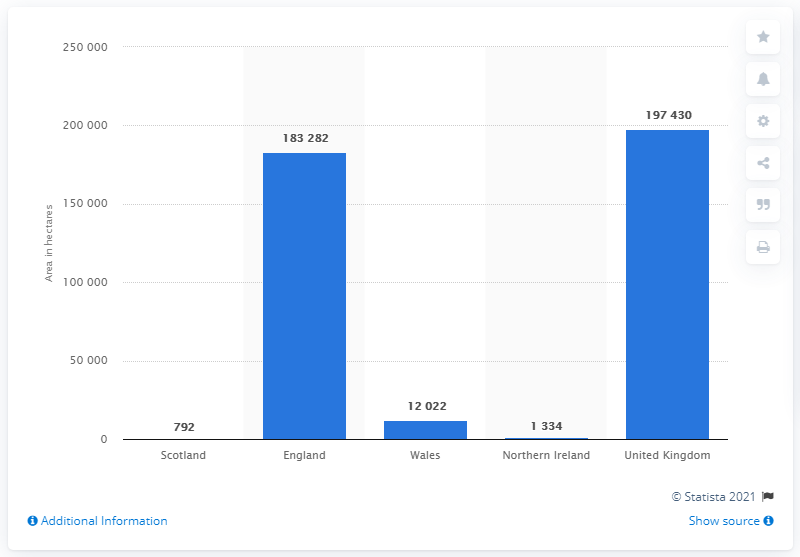Specify some key components in this picture. In June 2017, a total of 183,282 hectares of maize were grown in England. 